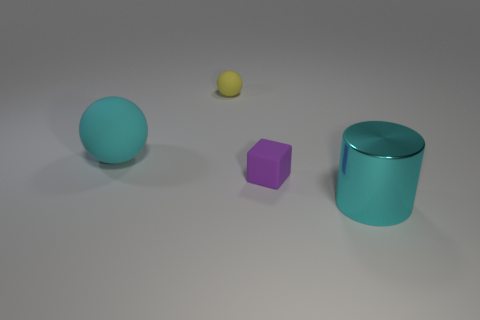Add 3 matte objects. How many objects exist? 7 Subtract all cubes. How many objects are left? 3 Add 4 cyan cylinders. How many cyan cylinders are left? 5 Add 1 tiny gray objects. How many tiny gray objects exist? 1 Subtract 0 blue cubes. How many objects are left? 4 Subtract all purple matte blocks. Subtract all tiny red cubes. How many objects are left? 3 